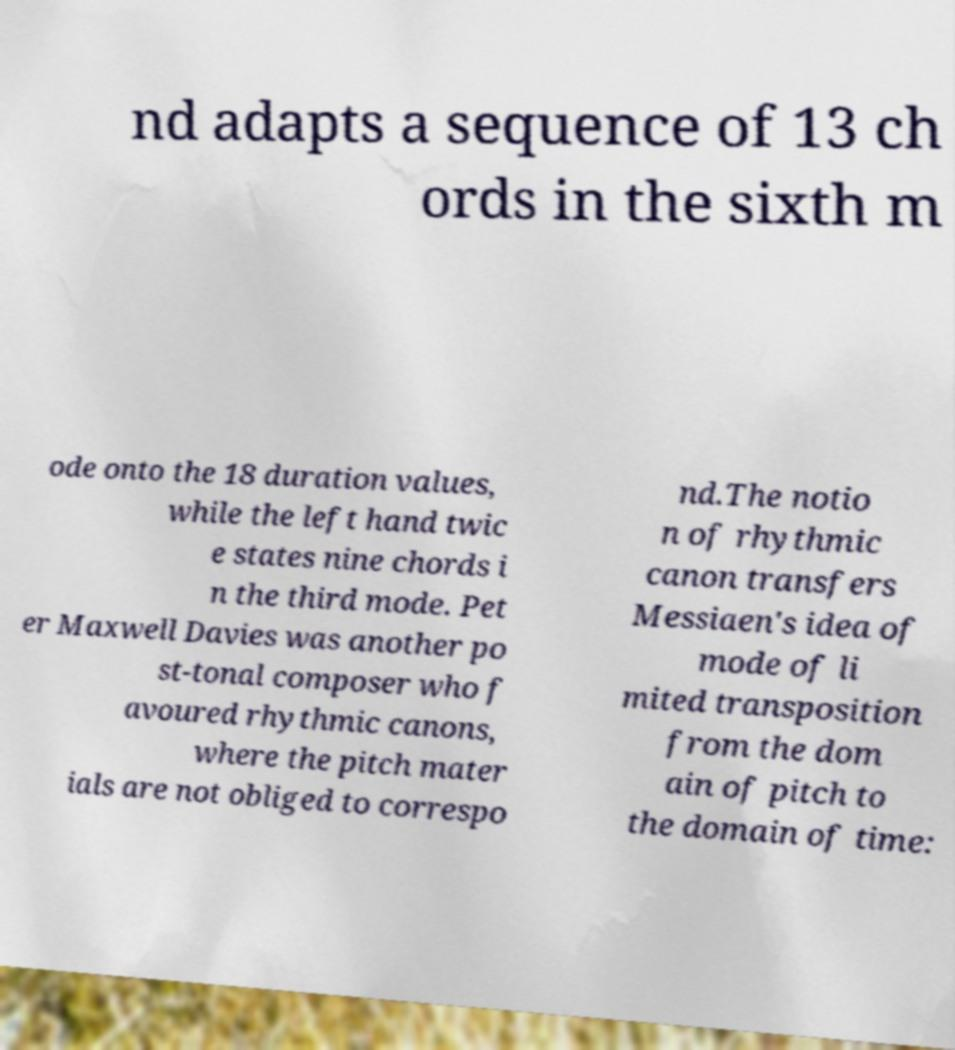Can you read and provide the text displayed in the image?This photo seems to have some interesting text. Can you extract and type it out for me? nd adapts a sequence of 13 ch ords in the sixth m ode onto the 18 duration values, while the left hand twic e states nine chords i n the third mode. Pet er Maxwell Davies was another po st-tonal composer who f avoured rhythmic canons, where the pitch mater ials are not obliged to correspo nd.The notio n of rhythmic canon transfers Messiaen's idea of mode of li mited transposition from the dom ain of pitch to the domain of time: 